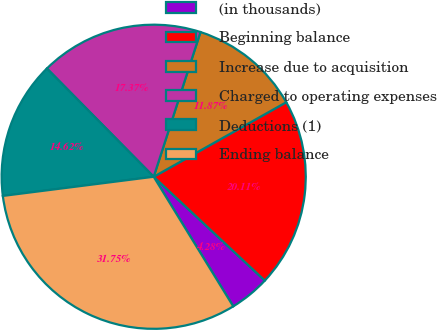Convert chart. <chart><loc_0><loc_0><loc_500><loc_500><pie_chart><fcel>(in thousands)<fcel>Beginning balance<fcel>Increase due to acquisition<fcel>Charged to operating expenses<fcel>Deductions (1)<fcel>Ending balance<nl><fcel>4.28%<fcel>20.11%<fcel>11.87%<fcel>17.37%<fcel>14.62%<fcel>31.75%<nl></chart> 